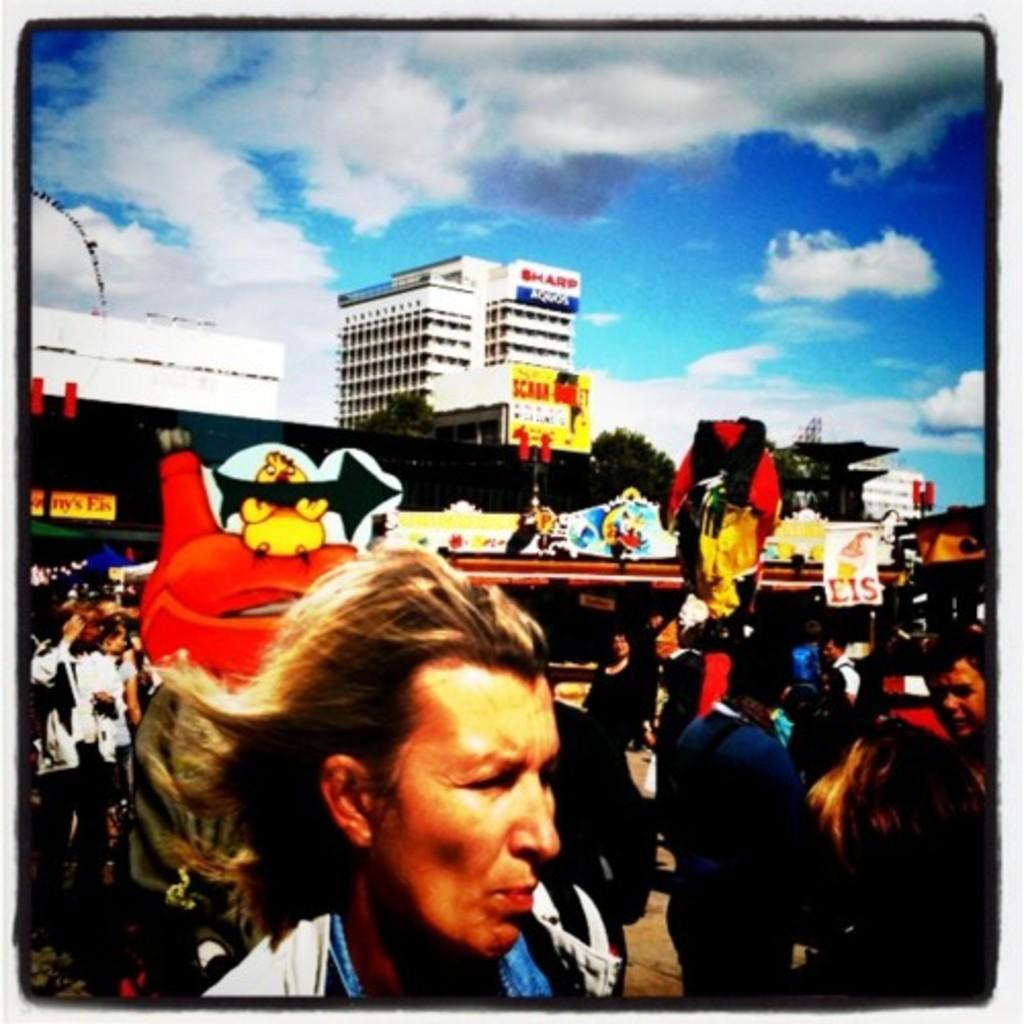Describe this image in one or two sentences. This is an image with the borders, in image there are buildings and group of people, trees and some playing things boards, toys and objects. At the top there is sky. 